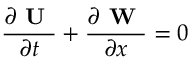Convert formula to latex. <formula><loc_0><loc_0><loc_500><loc_500>\frac { \partial U } { \partial t } + \frac { \partial W } { \partial x } = 0</formula> 